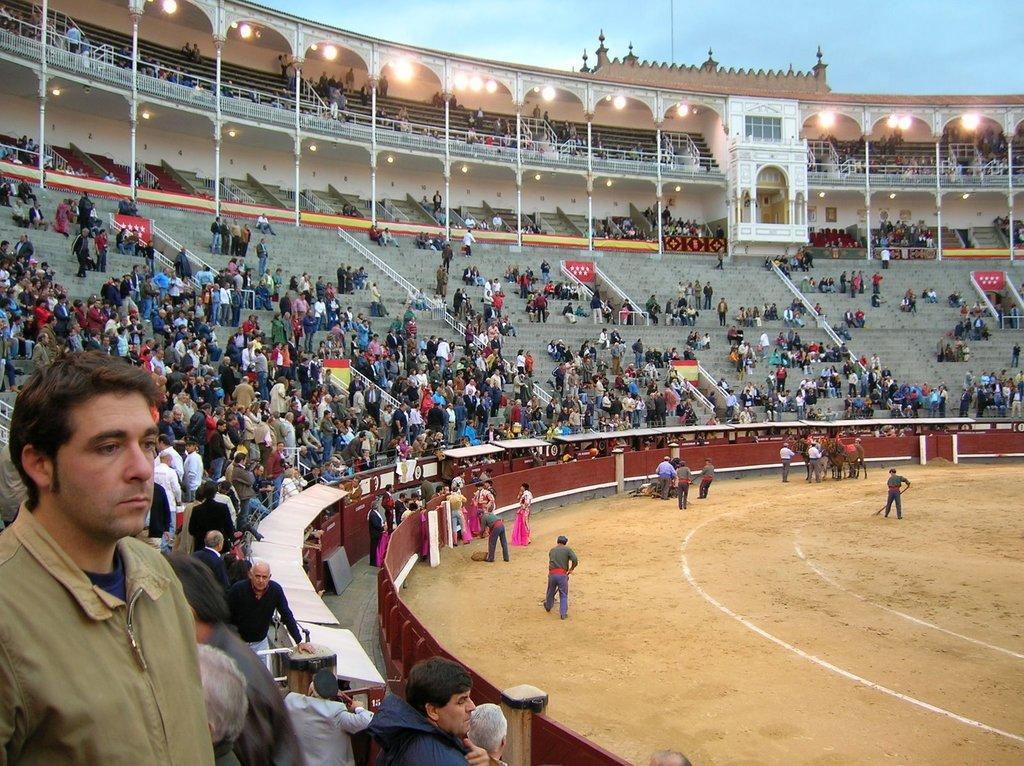Describe this image in one or two sentences. In this picture we can see a stadium. In the stadium, some people are sitting and some people are standing. Behind the people there are pillars and lights. Behind the stadium where is the sky. 